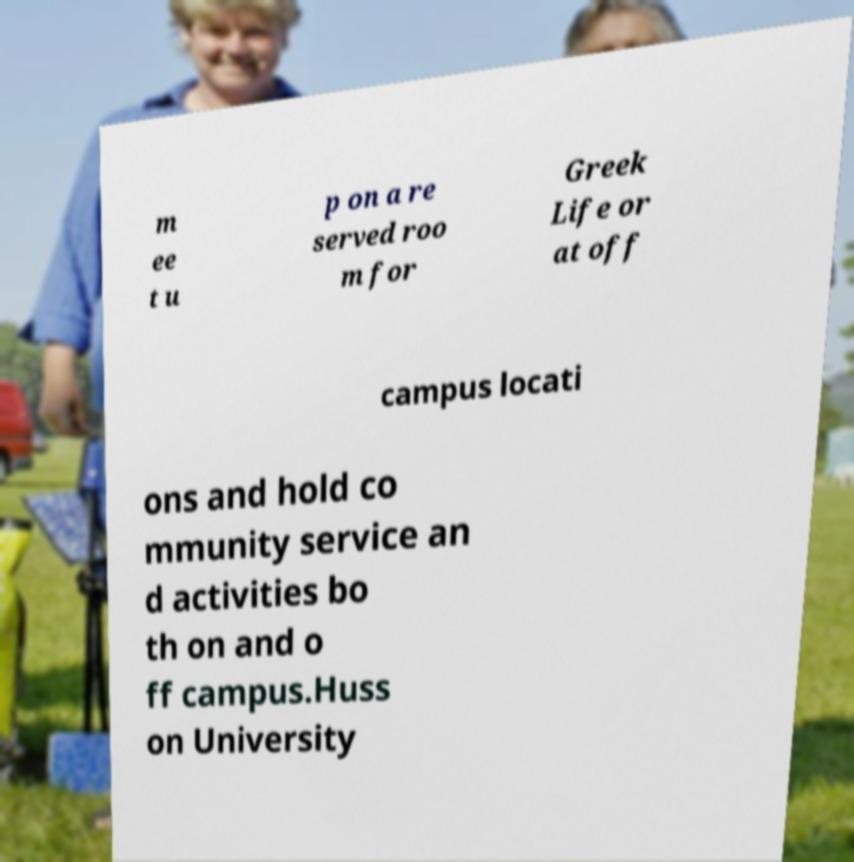What messages or text are displayed in this image? I need them in a readable, typed format. m ee t u p on a re served roo m for Greek Life or at off campus locati ons and hold co mmunity service an d activities bo th on and o ff campus.Huss on University 